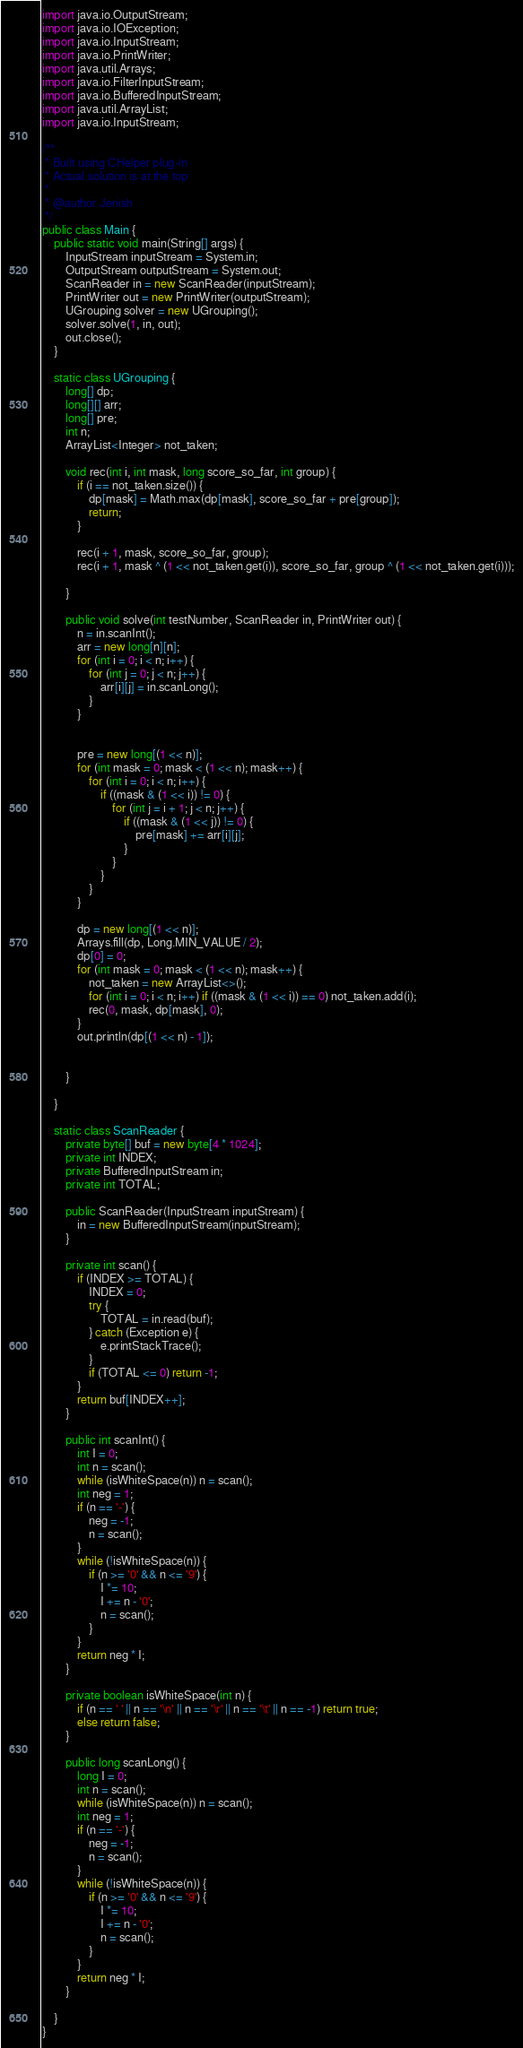<code> <loc_0><loc_0><loc_500><loc_500><_Java_>import java.io.OutputStream;
import java.io.IOException;
import java.io.InputStream;
import java.io.PrintWriter;
import java.util.Arrays;
import java.io.FilterInputStream;
import java.io.BufferedInputStream;
import java.util.ArrayList;
import java.io.InputStream;

/**
 * Built using CHelper plug-in
 * Actual solution is at the top
 *
 * @author Jenish
 */
public class Main {
    public static void main(String[] args) {
        InputStream inputStream = System.in;
        OutputStream outputStream = System.out;
        ScanReader in = new ScanReader(inputStream);
        PrintWriter out = new PrintWriter(outputStream);
        UGrouping solver = new UGrouping();
        solver.solve(1, in, out);
        out.close();
    }

    static class UGrouping {
        long[] dp;
        long[][] arr;
        long[] pre;
        int n;
        ArrayList<Integer> not_taken;

        void rec(int i, int mask, long score_so_far, int group) {
            if (i == not_taken.size()) {
                dp[mask] = Math.max(dp[mask], score_so_far + pre[group]);
                return;
            }

            rec(i + 1, mask, score_so_far, group);
            rec(i + 1, mask ^ (1 << not_taken.get(i)), score_so_far, group ^ (1 << not_taken.get(i)));

        }

        public void solve(int testNumber, ScanReader in, PrintWriter out) {
            n = in.scanInt();
            arr = new long[n][n];
            for (int i = 0; i < n; i++) {
                for (int j = 0; j < n; j++) {
                    arr[i][j] = in.scanLong();
                }
            }


            pre = new long[(1 << n)];
            for (int mask = 0; mask < (1 << n); mask++) {
                for (int i = 0; i < n; i++) {
                    if ((mask & (1 << i)) != 0) {
                        for (int j = i + 1; j < n; j++) {
                            if ((mask & (1 << j)) != 0) {
                                pre[mask] += arr[i][j];
                            }
                        }
                    }
                }
            }

            dp = new long[(1 << n)];
            Arrays.fill(dp, Long.MIN_VALUE / 2);
            dp[0] = 0;
            for (int mask = 0; mask < (1 << n); mask++) {
                not_taken = new ArrayList<>();
                for (int i = 0; i < n; i++) if ((mask & (1 << i)) == 0) not_taken.add(i);
                rec(0, mask, dp[mask], 0);
            }
            out.println(dp[(1 << n) - 1]);


        }

    }

    static class ScanReader {
        private byte[] buf = new byte[4 * 1024];
        private int INDEX;
        private BufferedInputStream in;
        private int TOTAL;

        public ScanReader(InputStream inputStream) {
            in = new BufferedInputStream(inputStream);
        }

        private int scan() {
            if (INDEX >= TOTAL) {
                INDEX = 0;
                try {
                    TOTAL = in.read(buf);
                } catch (Exception e) {
                    e.printStackTrace();
                }
                if (TOTAL <= 0) return -1;
            }
            return buf[INDEX++];
        }

        public int scanInt() {
            int I = 0;
            int n = scan();
            while (isWhiteSpace(n)) n = scan();
            int neg = 1;
            if (n == '-') {
                neg = -1;
                n = scan();
            }
            while (!isWhiteSpace(n)) {
                if (n >= '0' && n <= '9') {
                    I *= 10;
                    I += n - '0';
                    n = scan();
                }
            }
            return neg * I;
        }

        private boolean isWhiteSpace(int n) {
            if (n == ' ' || n == '\n' || n == '\r' || n == '\t' || n == -1) return true;
            else return false;
        }

        public long scanLong() {
            long I = 0;
            int n = scan();
            while (isWhiteSpace(n)) n = scan();
            int neg = 1;
            if (n == '-') {
                neg = -1;
                n = scan();
            }
            while (!isWhiteSpace(n)) {
                if (n >= '0' && n <= '9') {
                    I *= 10;
                    I += n - '0';
                    n = scan();
                }
            }
            return neg * I;
        }

    }
}

</code> 